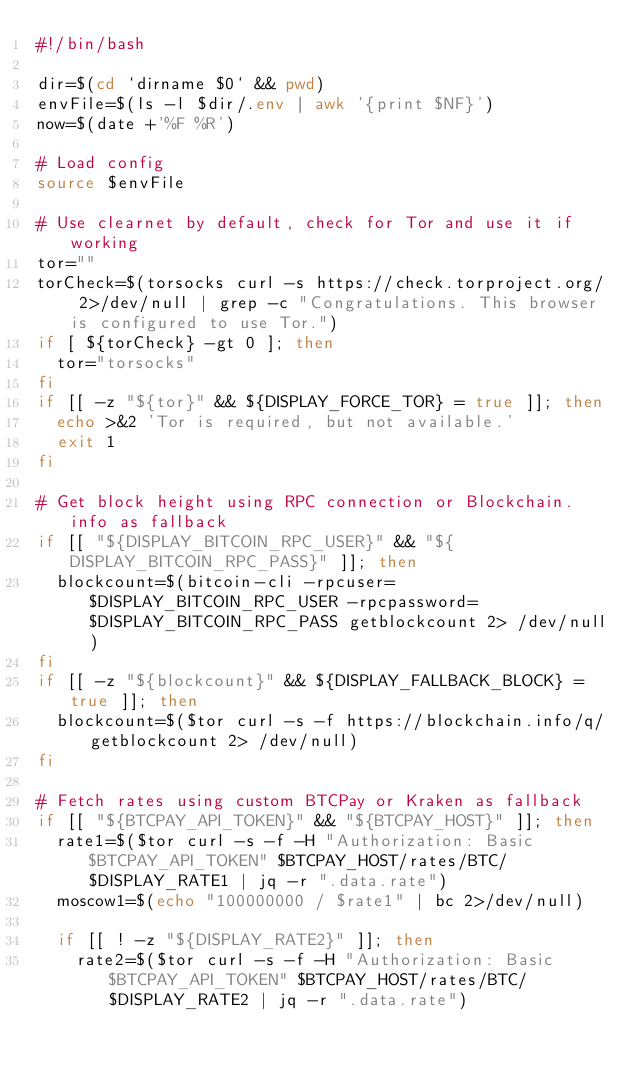Convert code to text. <code><loc_0><loc_0><loc_500><loc_500><_Bash_>#!/bin/bash

dir=$(cd `dirname $0` && pwd)
envFile=$(ls -l $dir/.env | awk '{print $NF}')
now=$(date +'%F %R')

# Load config
source $envFile

# Use clearnet by default, check for Tor and use it if working
tor=""
torCheck=$(torsocks curl -s https://check.torproject.org/ 2>/dev/null | grep -c "Congratulations. This browser is configured to use Tor.")
if [ ${torCheck} -gt 0 ]; then
  tor="torsocks"
fi
if [[ -z "${tor}" && ${DISPLAY_FORCE_TOR} = true ]]; then
  echo >&2 'Tor is required, but not available.'
  exit 1
fi

# Get block height using RPC connection or Blockchain.info as fallback
if [[ "${DISPLAY_BITCOIN_RPC_USER}" && "${DISPLAY_BITCOIN_RPC_PASS}" ]]; then
  blockcount=$(bitcoin-cli -rpcuser=$DISPLAY_BITCOIN_RPC_USER -rpcpassword=$DISPLAY_BITCOIN_RPC_PASS getblockcount 2> /dev/null)
fi
if [[ -z "${blockcount}" && ${DISPLAY_FALLBACK_BLOCK} = true ]]; then
  blockcount=$($tor curl -s -f https://blockchain.info/q/getblockcount 2> /dev/null)
fi

# Fetch rates using custom BTCPay or Kraken as fallback
if [[ "${BTCPAY_API_TOKEN}" && "${BTCPAY_HOST}" ]]; then
  rate1=$($tor curl -s -f -H "Authorization: Basic $BTCPAY_API_TOKEN" $BTCPAY_HOST/rates/BTC/$DISPLAY_RATE1 | jq -r ".data.rate")
  moscow1=$(echo "100000000 / $rate1" | bc 2>/dev/null)

  if [[ ! -z "${DISPLAY_RATE2}" ]]; then
    rate2=$($tor curl -s -f -H "Authorization: Basic $BTCPAY_API_TOKEN" $BTCPAY_HOST/rates/BTC/$DISPLAY_RATE2 | jq -r ".data.rate")</code> 